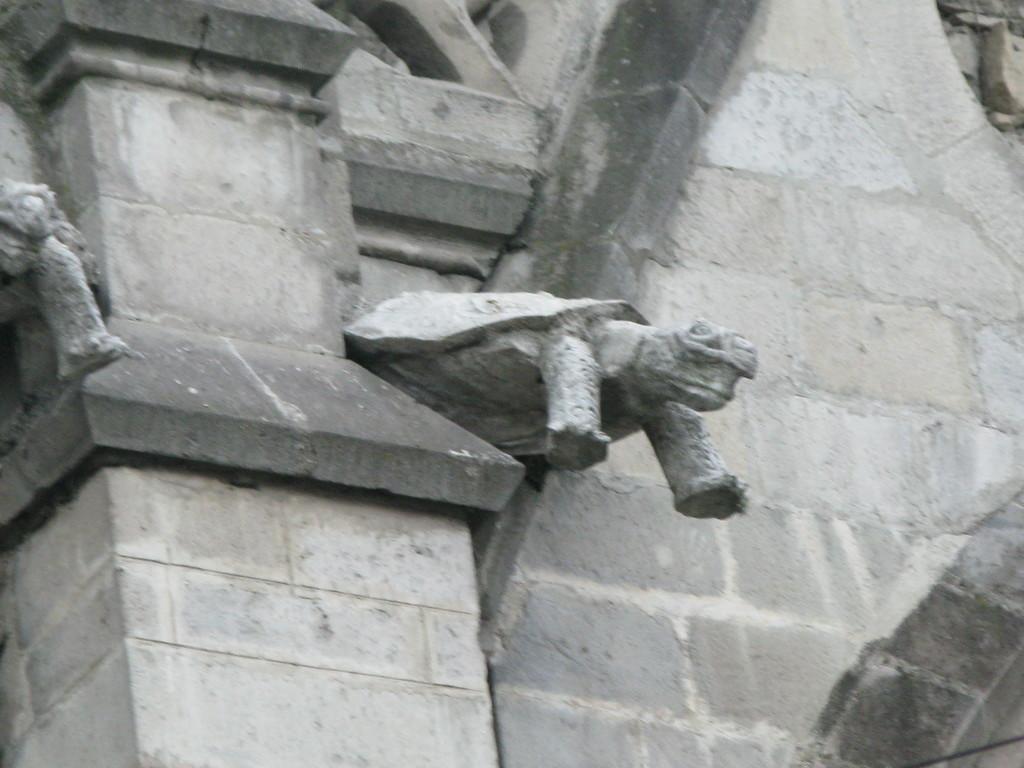In one or two sentences, can you explain what this image depicts? In this image I can see few status attached to the wall and the wall is in gray color. 